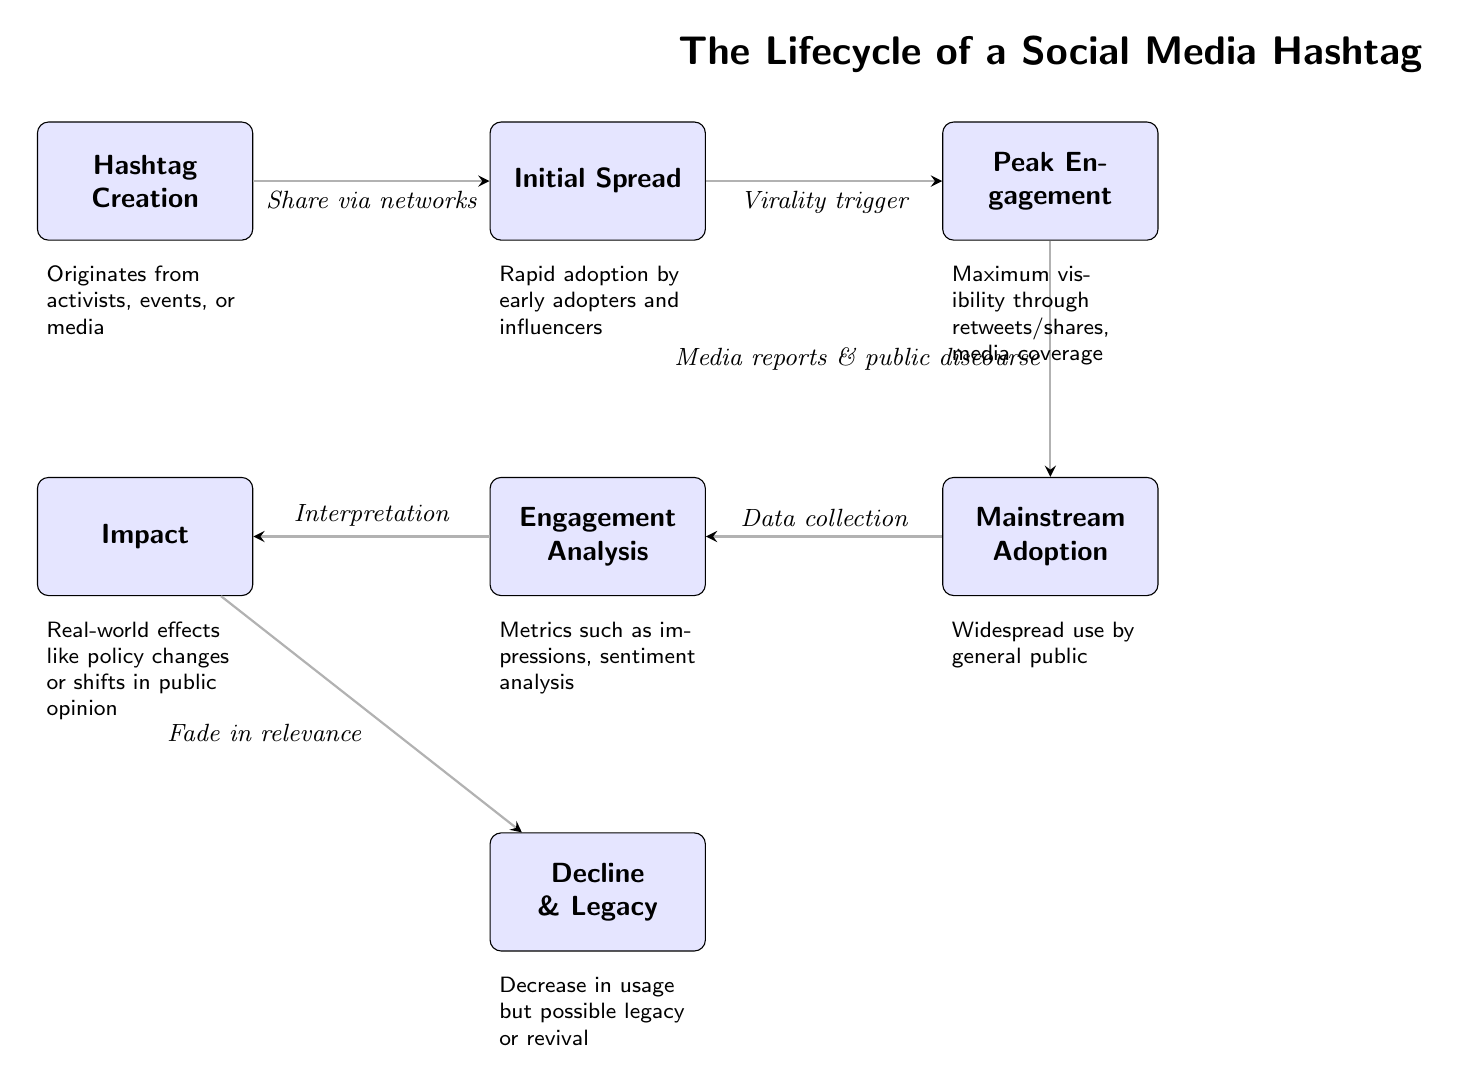What is the first stage in the lifecycle of a social media hashtag? The diagram indicates the first stage is "Hashtag Creation," where hashtags originate from activists, events, or media.
Answer: Hashtag Creation What is the fifth stage in the lifecycle? Counting the stages in the diagram, the fifth stage listed is "Engagement Analysis."
Answer: Engagement Analysis What action connects "Initial Spread" to "Peak Engagement"? The diagram shows that the action connecting these two stages is "Virality trigger."
Answer: Virality trigger How many total nodes are present in the diagram? By counting each distinct stage listed in the diagram, there are a total of seven nodes.
Answer: 7 What is interpreted from "Engagement Analysis"? The diagram states that from "Engagement Analysis," metrics such as impressions and sentiment analysis are collected.
Answer: Metrics such as impressions, sentiment analysis Which stage follows "Mainstream Adoption"? The diagram clearly indicates that "Engagement Analysis" follows the "Mainstream Adoption" stage.
Answer: Engagement Analysis What is the final outcome after the "Impact" stage? According to the diagram, the final outcome after "Impact" is "Decline & Legacy," indicating a decrease in usage but possible revival.
Answer: Decline & Legacy What does "Peak Engagement" rely on to achieve maximum visibility? The diagram specifies that "Peak Engagement" relies on "Media reports & public discourse" to achieve maximum visibility.
Answer: Media reports & public discourse What type of effects are associated with the "Impact" node? The diagram notes that "Impact" reflects real-world effects such as policy changes or shifts in public opinion.
Answer: Real-world effects like policy changes or shifts in public opinion 